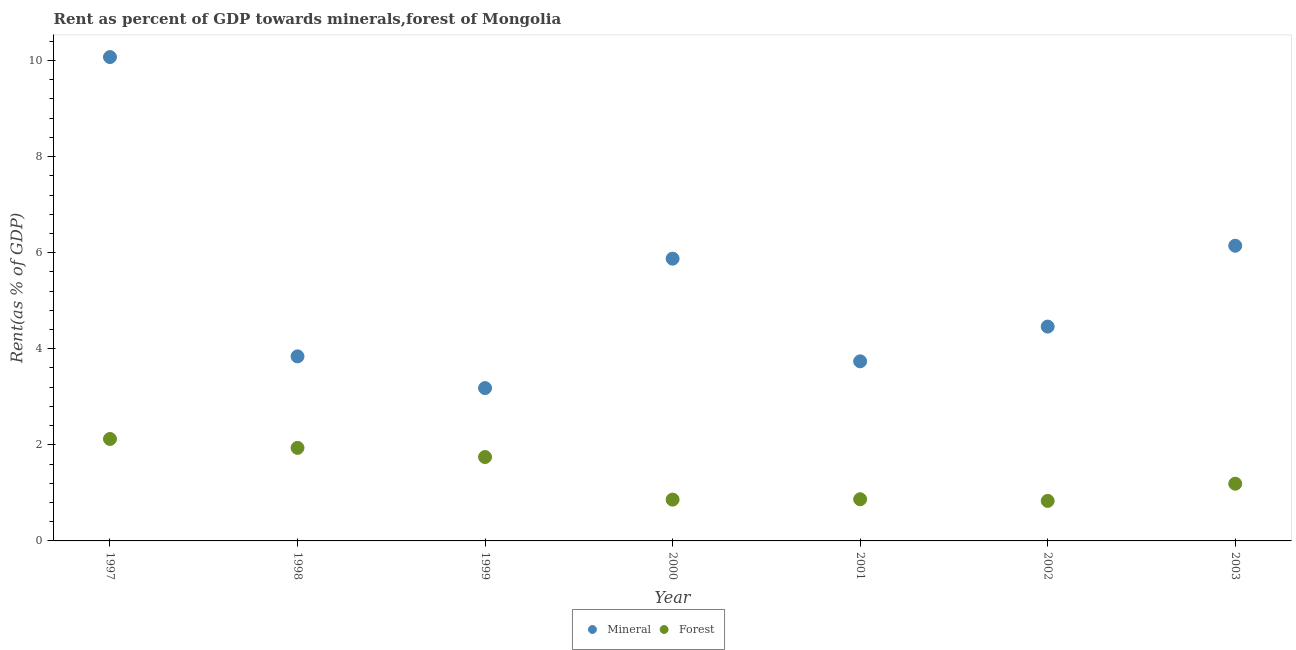How many different coloured dotlines are there?
Keep it short and to the point. 2. What is the forest rent in 1997?
Your answer should be very brief. 2.12. Across all years, what is the maximum mineral rent?
Your answer should be compact. 10.07. Across all years, what is the minimum mineral rent?
Ensure brevity in your answer.  3.18. In which year was the mineral rent maximum?
Offer a very short reply. 1997. In which year was the forest rent minimum?
Your answer should be compact. 2002. What is the total forest rent in the graph?
Ensure brevity in your answer.  9.56. What is the difference between the mineral rent in 1999 and that in 2000?
Your answer should be very brief. -2.69. What is the difference between the mineral rent in 2002 and the forest rent in 1998?
Offer a very short reply. 2.52. What is the average forest rent per year?
Your answer should be compact. 1.37. In the year 1999, what is the difference between the mineral rent and forest rent?
Your answer should be compact. 1.44. In how many years, is the forest rent greater than 9.6 %?
Your answer should be very brief. 0. What is the ratio of the forest rent in 1997 to that in 2003?
Provide a succinct answer. 1.78. Is the forest rent in 1999 less than that in 2003?
Offer a very short reply. No. Is the difference between the forest rent in 2000 and 2001 greater than the difference between the mineral rent in 2000 and 2001?
Offer a terse response. No. What is the difference between the highest and the second highest forest rent?
Provide a short and direct response. 0.19. What is the difference between the highest and the lowest forest rent?
Your answer should be very brief. 1.29. In how many years, is the mineral rent greater than the average mineral rent taken over all years?
Your answer should be compact. 3. Is the sum of the mineral rent in 1999 and 2001 greater than the maximum forest rent across all years?
Provide a succinct answer. Yes. Does the mineral rent monotonically increase over the years?
Your response must be concise. No. Is the forest rent strictly greater than the mineral rent over the years?
Make the answer very short. No. Is the forest rent strictly less than the mineral rent over the years?
Your response must be concise. Yes. How many dotlines are there?
Offer a terse response. 2. How many years are there in the graph?
Ensure brevity in your answer.  7. Does the graph contain any zero values?
Provide a short and direct response. No. Where does the legend appear in the graph?
Offer a terse response. Bottom center. What is the title of the graph?
Give a very brief answer. Rent as percent of GDP towards minerals,forest of Mongolia. Does "Age 65(female)" appear as one of the legend labels in the graph?
Your response must be concise. No. What is the label or title of the X-axis?
Your answer should be very brief. Year. What is the label or title of the Y-axis?
Your answer should be very brief. Rent(as % of GDP). What is the Rent(as % of GDP) of Mineral in 1997?
Offer a terse response. 10.07. What is the Rent(as % of GDP) of Forest in 1997?
Offer a very short reply. 2.12. What is the Rent(as % of GDP) in Mineral in 1998?
Ensure brevity in your answer.  3.84. What is the Rent(as % of GDP) of Forest in 1998?
Your answer should be very brief. 1.94. What is the Rent(as % of GDP) in Mineral in 1999?
Make the answer very short. 3.18. What is the Rent(as % of GDP) in Forest in 1999?
Keep it short and to the point. 1.75. What is the Rent(as % of GDP) of Mineral in 2000?
Offer a terse response. 5.88. What is the Rent(as % of GDP) in Forest in 2000?
Keep it short and to the point. 0.86. What is the Rent(as % of GDP) of Mineral in 2001?
Your answer should be compact. 3.74. What is the Rent(as % of GDP) in Forest in 2001?
Provide a short and direct response. 0.87. What is the Rent(as % of GDP) of Mineral in 2002?
Offer a very short reply. 4.46. What is the Rent(as % of GDP) of Forest in 2002?
Make the answer very short. 0.83. What is the Rent(as % of GDP) of Mineral in 2003?
Keep it short and to the point. 6.14. What is the Rent(as % of GDP) of Forest in 2003?
Provide a succinct answer. 1.19. Across all years, what is the maximum Rent(as % of GDP) of Mineral?
Offer a terse response. 10.07. Across all years, what is the maximum Rent(as % of GDP) of Forest?
Provide a succinct answer. 2.12. Across all years, what is the minimum Rent(as % of GDP) in Mineral?
Provide a short and direct response. 3.18. Across all years, what is the minimum Rent(as % of GDP) in Forest?
Provide a succinct answer. 0.83. What is the total Rent(as % of GDP) of Mineral in the graph?
Make the answer very short. 37.32. What is the total Rent(as % of GDP) in Forest in the graph?
Make the answer very short. 9.56. What is the difference between the Rent(as % of GDP) in Mineral in 1997 and that in 1998?
Provide a short and direct response. 6.23. What is the difference between the Rent(as % of GDP) of Forest in 1997 and that in 1998?
Your response must be concise. 0.19. What is the difference between the Rent(as % of GDP) of Mineral in 1997 and that in 1999?
Offer a very short reply. 6.89. What is the difference between the Rent(as % of GDP) of Forest in 1997 and that in 1999?
Your answer should be compact. 0.38. What is the difference between the Rent(as % of GDP) of Mineral in 1997 and that in 2000?
Offer a terse response. 4.2. What is the difference between the Rent(as % of GDP) of Forest in 1997 and that in 2000?
Ensure brevity in your answer.  1.26. What is the difference between the Rent(as % of GDP) in Mineral in 1997 and that in 2001?
Offer a terse response. 6.33. What is the difference between the Rent(as % of GDP) in Forest in 1997 and that in 2001?
Offer a very short reply. 1.25. What is the difference between the Rent(as % of GDP) of Mineral in 1997 and that in 2002?
Your answer should be very brief. 5.61. What is the difference between the Rent(as % of GDP) of Forest in 1997 and that in 2002?
Make the answer very short. 1.29. What is the difference between the Rent(as % of GDP) in Mineral in 1997 and that in 2003?
Your answer should be compact. 3.93. What is the difference between the Rent(as % of GDP) of Forest in 1997 and that in 2003?
Provide a short and direct response. 0.93. What is the difference between the Rent(as % of GDP) in Mineral in 1998 and that in 1999?
Ensure brevity in your answer.  0.66. What is the difference between the Rent(as % of GDP) in Forest in 1998 and that in 1999?
Make the answer very short. 0.19. What is the difference between the Rent(as % of GDP) of Mineral in 1998 and that in 2000?
Provide a succinct answer. -2.03. What is the difference between the Rent(as % of GDP) in Forest in 1998 and that in 2000?
Ensure brevity in your answer.  1.08. What is the difference between the Rent(as % of GDP) of Mineral in 1998 and that in 2001?
Ensure brevity in your answer.  0.1. What is the difference between the Rent(as % of GDP) of Forest in 1998 and that in 2001?
Your answer should be compact. 1.07. What is the difference between the Rent(as % of GDP) in Mineral in 1998 and that in 2002?
Your answer should be very brief. -0.62. What is the difference between the Rent(as % of GDP) in Forest in 1998 and that in 2002?
Ensure brevity in your answer.  1.1. What is the difference between the Rent(as % of GDP) in Mineral in 1998 and that in 2003?
Provide a short and direct response. -2.3. What is the difference between the Rent(as % of GDP) of Forest in 1998 and that in 2003?
Provide a succinct answer. 0.75. What is the difference between the Rent(as % of GDP) of Mineral in 1999 and that in 2000?
Give a very brief answer. -2.69. What is the difference between the Rent(as % of GDP) in Forest in 1999 and that in 2000?
Your answer should be very brief. 0.89. What is the difference between the Rent(as % of GDP) in Mineral in 1999 and that in 2001?
Your response must be concise. -0.56. What is the difference between the Rent(as % of GDP) of Forest in 1999 and that in 2001?
Make the answer very short. 0.88. What is the difference between the Rent(as % of GDP) of Mineral in 1999 and that in 2002?
Offer a terse response. -1.28. What is the difference between the Rent(as % of GDP) in Mineral in 1999 and that in 2003?
Keep it short and to the point. -2.96. What is the difference between the Rent(as % of GDP) in Forest in 1999 and that in 2003?
Provide a succinct answer. 0.56. What is the difference between the Rent(as % of GDP) in Mineral in 2000 and that in 2001?
Your answer should be very brief. 2.14. What is the difference between the Rent(as % of GDP) of Forest in 2000 and that in 2001?
Provide a short and direct response. -0.01. What is the difference between the Rent(as % of GDP) of Mineral in 2000 and that in 2002?
Your response must be concise. 1.41. What is the difference between the Rent(as % of GDP) in Forest in 2000 and that in 2002?
Your answer should be very brief. 0.03. What is the difference between the Rent(as % of GDP) in Mineral in 2000 and that in 2003?
Your response must be concise. -0.27. What is the difference between the Rent(as % of GDP) of Forest in 2000 and that in 2003?
Your answer should be compact. -0.33. What is the difference between the Rent(as % of GDP) of Mineral in 2001 and that in 2002?
Provide a succinct answer. -0.72. What is the difference between the Rent(as % of GDP) in Forest in 2001 and that in 2002?
Ensure brevity in your answer.  0.03. What is the difference between the Rent(as % of GDP) in Mineral in 2001 and that in 2003?
Your response must be concise. -2.41. What is the difference between the Rent(as % of GDP) in Forest in 2001 and that in 2003?
Your response must be concise. -0.32. What is the difference between the Rent(as % of GDP) of Mineral in 2002 and that in 2003?
Keep it short and to the point. -1.68. What is the difference between the Rent(as % of GDP) of Forest in 2002 and that in 2003?
Give a very brief answer. -0.36. What is the difference between the Rent(as % of GDP) of Mineral in 1997 and the Rent(as % of GDP) of Forest in 1998?
Give a very brief answer. 8.14. What is the difference between the Rent(as % of GDP) in Mineral in 1997 and the Rent(as % of GDP) in Forest in 1999?
Your answer should be very brief. 8.33. What is the difference between the Rent(as % of GDP) in Mineral in 1997 and the Rent(as % of GDP) in Forest in 2000?
Provide a short and direct response. 9.21. What is the difference between the Rent(as % of GDP) of Mineral in 1997 and the Rent(as % of GDP) of Forest in 2001?
Offer a terse response. 9.2. What is the difference between the Rent(as % of GDP) of Mineral in 1997 and the Rent(as % of GDP) of Forest in 2002?
Ensure brevity in your answer.  9.24. What is the difference between the Rent(as % of GDP) of Mineral in 1997 and the Rent(as % of GDP) of Forest in 2003?
Make the answer very short. 8.88. What is the difference between the Rent(as % of GDP) in Mineral in 1998 and the Rent(as % of GDP) in Forest in 1999?
Your answer should be compact. 2.1. What is the difference between the Rent(as % of GDP) of Mineral in 1998 and the Rent(as % of GDP) of Forest in 2000?
Your response must be concise. 2.98. What is the difference between the Rent(as % of GDP) in Mineral in 1998 and the Rent(as % of GDP) in Forest in 2001?
Your response must be concise. 2.97. What is the difference between the Rent(as % of GDP) in Mineral in 1998 and the Rent(as % of GDP) in Forest in 2002?
Ensure brevity in your answer.  3.01. What is the difference between the Rent(as % of GDP) in Mineral in 1998 and the Rent(as % of GDP) in Forest in 2003?
Your answer should be compact. 2.65. What is the difference between the Rent(as % of GDP) in Mineral in 1999 and the Rent(as % of GDP) in Forest in 2000?
Keep it short and to the point. 2.32. What is the difference between the Rent(as % of GDP) of Mineral in 1999 and the Rent(as % of GDP) of Forest in 2001?
Your answer should be compact. 2.31. What is the difference between the Rent(as % of GDP) in Mineral in 1999 and the Rent(as % of GDP) in Forest in 2002?
Offer a terse response. 2.35. What is the difference between the Rent(as % of GDP) of Mineral in 1999 and the Rent(as % of GDP) of Forest in 2003?
Provide a succinct answer. 1.99. What is the difference between the Rent(as % of GDP) in Mineral in 2000 and the Rent(as % of GDP) in Forest in 2001?
Offer a terse response. 5.01. What is the difference between the Rent(as % of GDP) in Mineral in 2000 and the Rent(as % of GDP) in Forest in 2002?
Give a very brief answer. 5.04. What is the difference between the Rent(as % of GDP) of Mineral in 2000 and the Rent(as % of GDP) of Forest in 2003?
Your answer should be very brief. 4.68. What is the difference between the Rent(as % of GDP) of Mineral in 2001 and the Rent(as % of GDP) of Forest in 2002?
Make the answer very short. 2.91. What is the difference between the Rent(as % of GDP) in Mineral in 2001 and the Rent(as % of GDP) in Forest in 2003?
Offer a very short reply. 2.55. What is the difference between the Rent(as % of GDP) in Mineral in 2002 and the Rent(as % of GDP) in Forest in 2003?
Offer a very short reply. 3.27. What is the average Rent(as % of GDP) of Mineral per year?
Provide a succinct answer. 5.33. What is the average Rent(as % of GDP) in Forest per year?
Offer a very short reply. 1.37. In the year 1997, what is the difference between the Rent(as % of GDP) of Mineral and Rent(as % of GDP) of Forest?
Your answer should be very brief. 7.95. In the year 1998, what is the difference between the Rent(as % of GDP) in Mineral and Rent(as % of GDP) in Forest?
Provide a succinct answer. 1.9. In the year 1999, what is the difference between the Rent(as % of GDP) in Mineral and Rent(as % of GDP) in Forest?
Provide a short and direct response. 1.44. In the year 2000, what is the difference between the Rent(as % of GDP) in Mineral and Rent(as % of GDP) in Forest?
Your answer should be compact. 5.02. In the year 2001, what is the difference between the Rent(as % of GDP) of Mineral and Rent(as % of GDP) of Forest?
Make the answer very short. 2.87. In the year 2002, what is the difference between the Rent(as % of GDP) of Mineral and Rent(as % of GDP) of Forest?
Offer a very short reply. 3.63. In the year 2003, what is the difference between the Rent(as % of GDP) in Mineral and Rent(as % of GDP) in Forest?
Your answer should be very brief. 4.95. What is the ratio of the Rent(as % of GDP) of Mineral in 1997 to that in 1998?
Offer a terse response. 2.62. What is the ratio of the Rent(as % of GDP) in Forest in 1997 to that in 1998?
Offer a terse response. 1.1. What is the ratio of the Rent(as % of GDP) in Mineral in 1997 to that in 1999?
Keep it short and to the point. 3.17. What is the ratio of the Rent(as % of GDP) in Forest in 1997 to that in 1999?
Your answer should be very brief. 1.22. What is the ratio of the Rent(as % of GDP) in Mineral in 1997 to that in 2000?
Give a very brief answer. 1.71. What is the ratio of the Rent(as % of GDP) in Forest in 1997 to that in 2000?
Keep it short and to the point. 2.47. What is the ratio of the Rent(as % of GDP) of Mineral in 1997 to that in 2001?
Your response must be concise. 2.69. What is the ratio of the Rent(as % of GDP) of Forest in 1997 to that in 2001?
Your answer should be compact. 2.45. What is the ratio of the Rent(as % of GDP) of Mineral in 1997 to that in 2002?
Provide a succinct answer. 2.26. What is the ratio of the Rent(as % of GDP) in Forest in 1997 to that in 2002?
Your answer should be compact. 2.55. What is the ratio of the Rent(as % of GDP) of Mineral in 1997 to that in 2003?
Offer a terse response. 1.64. What is the ratio of the Rent(as % of GDP) in Forest in 1997 to that in 2003?
Offer a terse response. 1.78. What is the ratio of the Rent(as % of GDP) of Mineral in 1998 to that in 1999?
Offer a very short reply. 1.21. What is the ratio of the Rent(as % of GDP) in Forest in 1998 to that in 1999?
Your answer should be very brief. 1.11. What is the ratio of the Rent(as % of GDP) of Mineral in 1998 to that in 2000?
Make the answer very short. 0.65. What is the ratio of the Rent(as % of GDP) of Forest in 1998 to that in 2000?
Keep it short and to the point. 2.25. What is the ratio of the Rent(as % of GDP) in Mineral in 1998 to that in 2001?
Offer a terse response. 1.03. What is the ratio of the Rent(as % of GDP) in Forest in 1998 to that in 2001?
Make the answer very short. 2.23. What is the ratio of the Rent(as % of GDP) in Mineral in 1998 to that in 2002?
Keep it short and to the point. 0.86. What is the ratio of the Rent(as % of GDP) in Forest in 1998 to that in 2002?
Make the answer very short. 2.32. What is the ratio of the Rent(as % of GDP) of Mineral in 1998 to that in 2003?
Your answer should be very brief. 0.63. What is the ratio of the Rent(as % of GDP) of Forest in 1998 to that in 2003?
Your answer should be very brief. 1.63. What is the ratio of the Rent(as % of GDP) in Mineral in 1999 to that in 2000?
Make the answer very short. 0.54. What is the ratio of the Rent(as % of GDP) in Forest in 1999 to that in 2000?
Offer a terse response. 2.03. What is the ratio of the Rent(as % of GDP) of Mineral in 1999 to that in 2001?
Offer a very short reply. 0.85. What is the ratio of the Rent(as % of GDP) in Forest in 1999 to that in 2001?
Make the answer very short. 2.01. What is the ratio of the Rent(as % of GDP) in Mineral in 1999 to that in 2002?
Provide a succinct answer. 0.71. What is the ratio of the Rent(as % of GDP) of Forest in 1999 to that in 2002?
Your response must be concise. 2.1. What is the ratio of the Rent(as % of GDP) of Mineral in 1999 to that in 2003?
Make the answer very short. 0.52. What is the ratio of the Rent(as % of GDP) in Forest in 1999 to that in 2003?
Provide a short and direct response. 1.47. What is the ratio of the Rent(as % of GDP) of Mineral in 2000 to that in 2001?
Your answer should be compact. 1.57. What is the ratio of the Rent(as % of GDP) in Forest in 2000 to that in 2001?
Your answer should be very brief. 0.99. What is the ratio of the Rent(as % of GDP) of Mineral in 2000 to that in 2002?
Offer a very short reply. 1.32. What is the ratio of the Rent(as % of GDP) of Forest in 2000 to that in 2002?
Ensure brevity in your answer.  1.03. What is the ratio of the Rent(as % of GDP) in Mineral in 2000 to that in 2003?
Provide a short and direct response. 0.96. What is the ratio of the Rent(as % of GDP) of Forest in 2000 to that in 2003?
Give a very brief answer. 0.72. What is the ratio of the Rent(as % of GDP) in Mineral in 2001 to that in 2002?
Your answer should be compact. 0.84. What is the ratio of the Rent(as % of GDP) in Forest in 2001 to that in 2002?
Offer a terse response. 1.04. What is the ratio of the Rent(as % of GDP) of Mineral in 2001 to that in 2003?
Make the answer very short. 0.61. What is the ratio of the Rent(as % of GDP) in Forest in 2001 to that in 2003?
Your answer should be very brief. 0.73. What is the ratio of the Rent(as % of GDP) in Mineral in 2002 to that in 2003?
Offer a terse response. 0.73. What is the ratio of the Rent(as % of GDP) in Forest in 2002 to that in 2003?
Keep it short and to the point. 0.7. What is the difference between the highest and the second highest Rent(as % of GDP) of Mineral?
Ensure brevity in your answer.  3.93. What is the difference between the highest and the second highest Rent(as % of GDP) in Forest?
Give a very brief answer. 0.19. What is the difference between the highest and the lowest Rent(as % of GDP) of Mineral?
Keep it short and to the point. 6.89. What is the difference between the highest and the lowest Rent(as % of GDP) in Forest?
Provide a short and direct response. 1.29. 